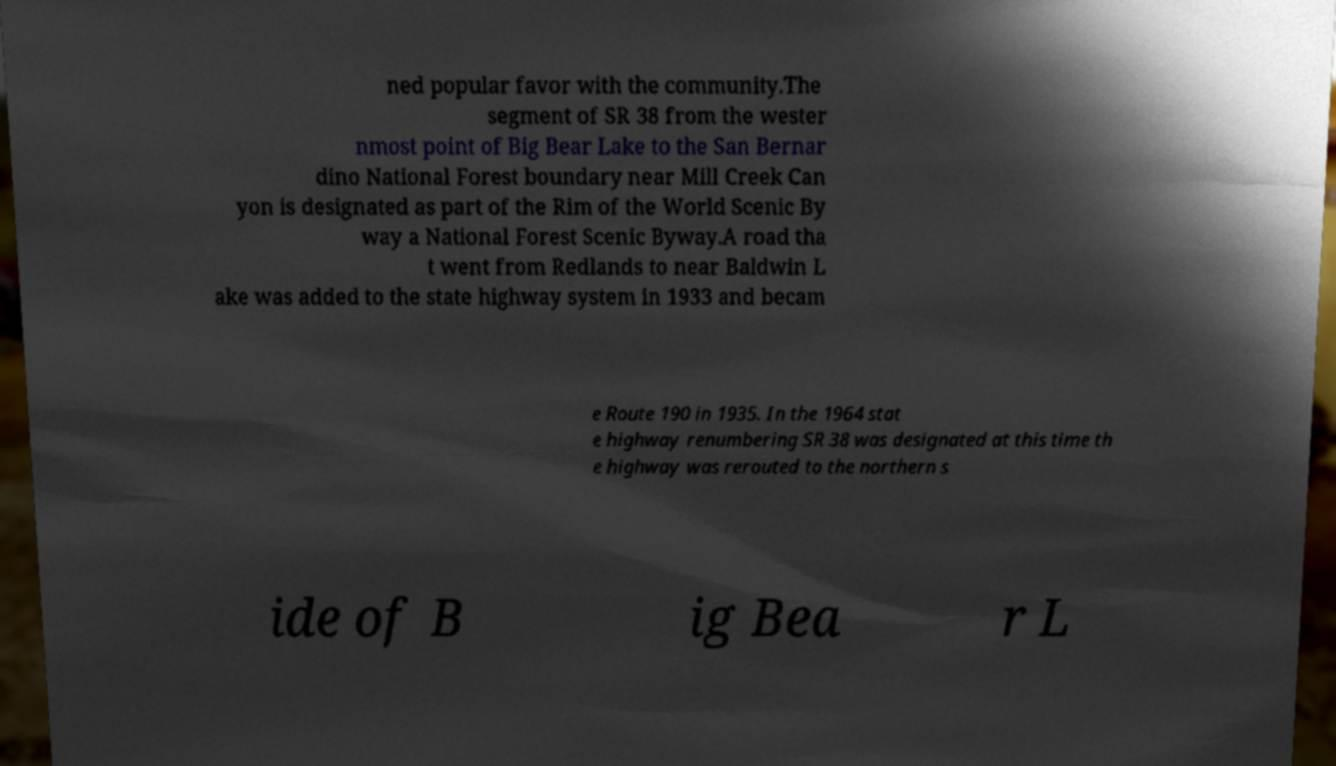Could you extract and type out the text from this image? ned popular favor with the community.The segment of SR 38 from the wester nmost point of Big Bear Lake to the San Bernar dino National Forest boundary near Mill Creek Can yon is designated as part of the Rim of the World Scenic By way a National Forest Scenic Byway.A road tha t went from Redlands to near Baldwin L ake was added to the state highway system in 1933 and becam e Route 190 in 1935. In the 1964 stat e highway renumbering SR 38 was designated at this time th e highway was rerouted to the northern s ide of B ig Bea r L 